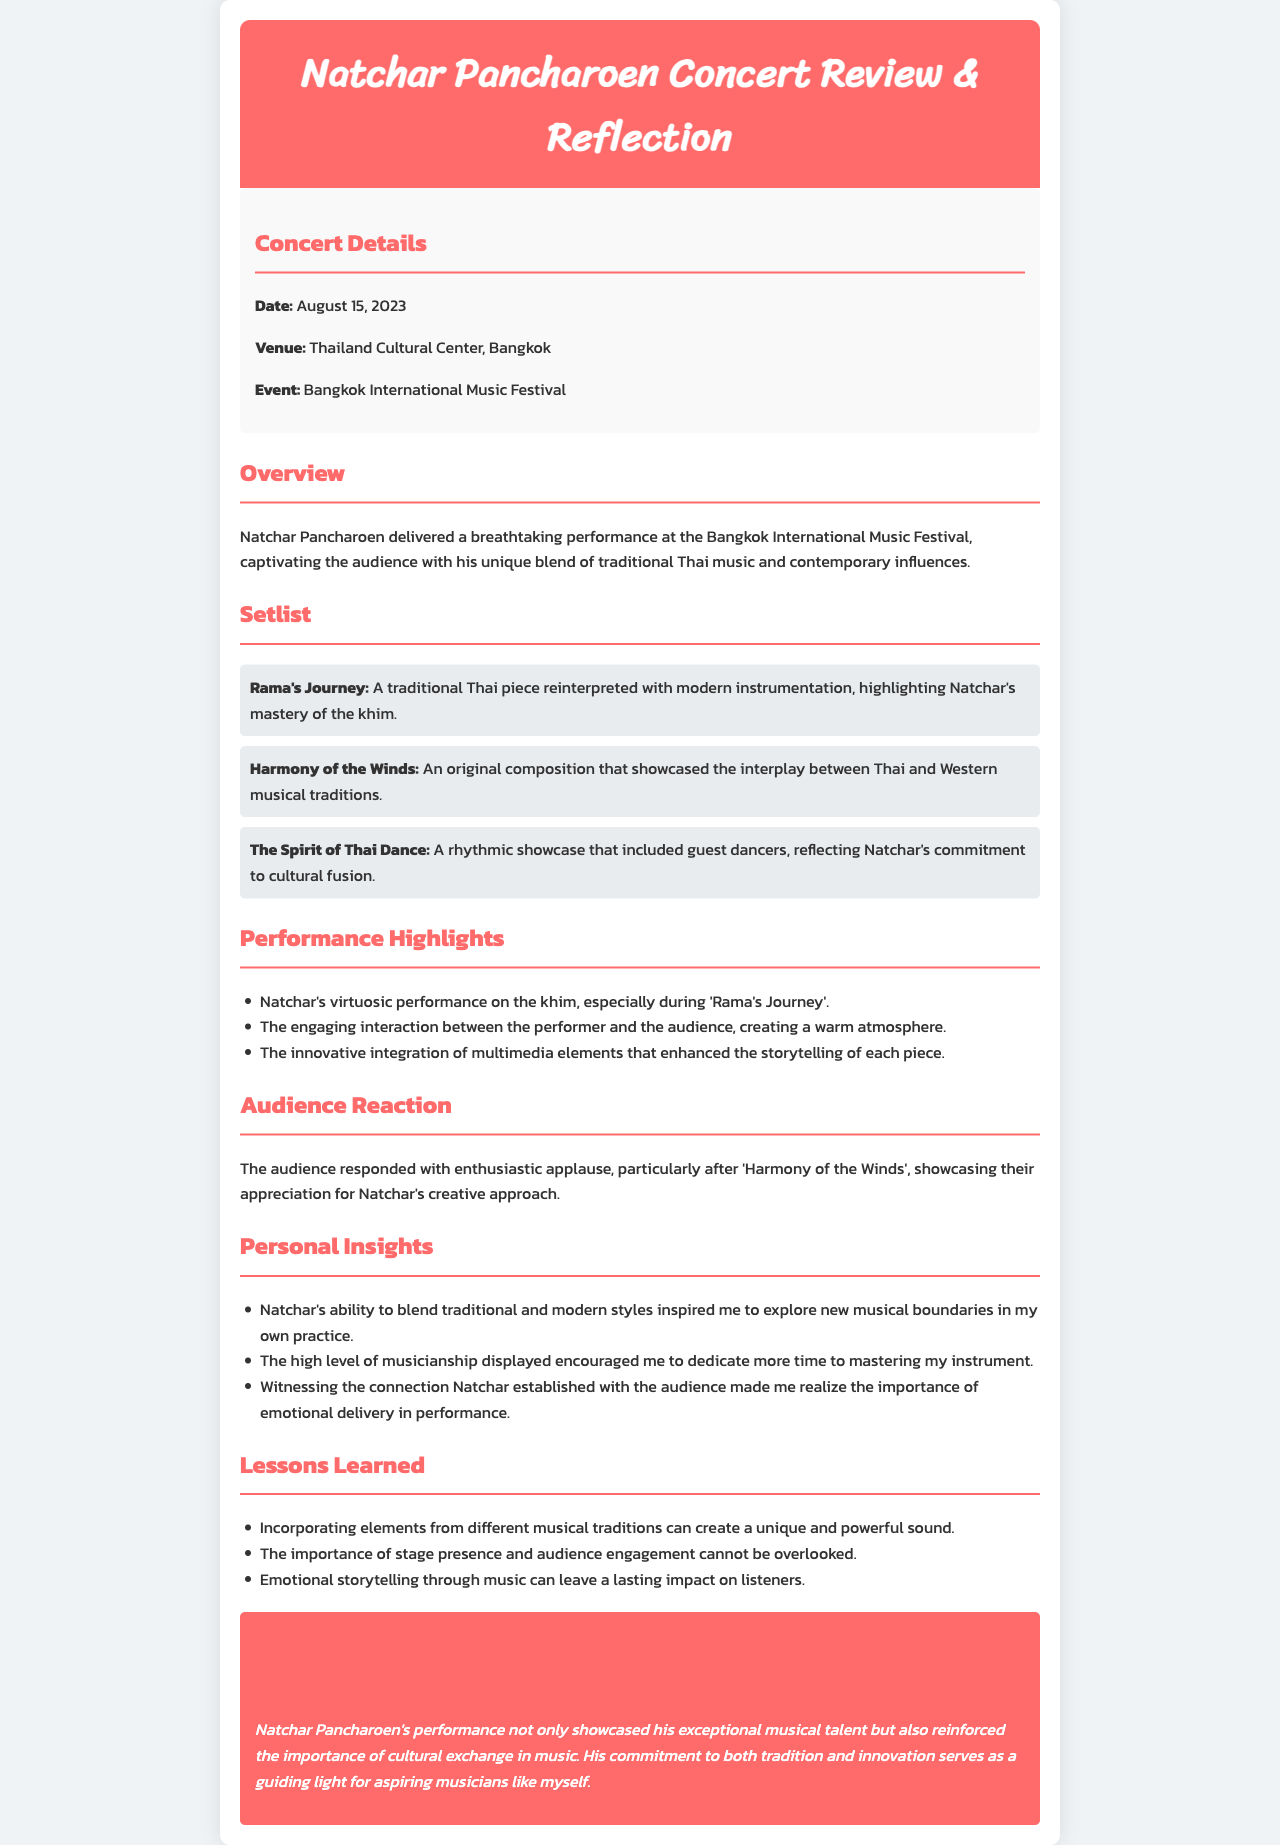What is the date of the concert? The date of the concert is mentioned in the "Concert Details" section as August 15, 2023.
Answer: August 15, 2023 Where was the concert held? The venue is stated in the "Concert Details" section, which is the Thailand Cultural Center, Bangkok.
Answer: Thailand Cultural Center, Bangkok What was the title of the piece that showcased the khim? The piece highlighting the khim is referred to in the "Setlist" section as "Rama's Journey".
Answer: Rama's Journey What was the audience's response after 'Harmony of the Winds'? The document mentions that the audience responded with enthusiastic applause, specifically after 'Harmony of the Winds'.
Answer: Enthusiastic applause What is one of the key insights gained from witnessing Natchar's performance? Natchar's performance inspired the reflection that blending traditional and modern styles can open new musical boundaries.
Answer: Blending traditional and modern styles What is one lesson learned from the concert? The lessons learned include the significant impact of emotional storytelling through music.
Answer: Emotional storytelling through music What event was associated with Natchar Pancharoen's concert? The concert is linked to the Bangkok International Music Festival, noted in the "Concert Details" section.
Answer: Bangkok International Music Festival What did Natchar integrate into his performance that enhanced storytelling? The document notes the innovative integration of multimedia elements during the performance.
Answer: Multimedia elements What instrument did Natchar Pancharoen play? The performance showcases Natchar's mastery of the khim, clearly mentioned in the "Setlist".
Answer: Khim 